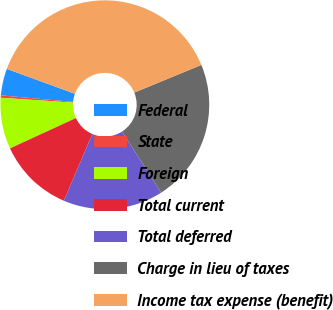Convert chart to OTSL. <chart><loc_0><loc_0><loc_500><loc_500><pie_chart><fcel>Federal<fcel>State<fcel>Foreign<fcel>Total current<fcel>Total deferred<fcel>Charge in lieu of taxes<fcel>Income tax expense (benefit)<nl><fcel>4.15%<fcel>0.37%<fcel>7.93%<fcel>11.71%<fcel>15.5%<fcel>22.15%<fcel>38.19%<nl></chart> 